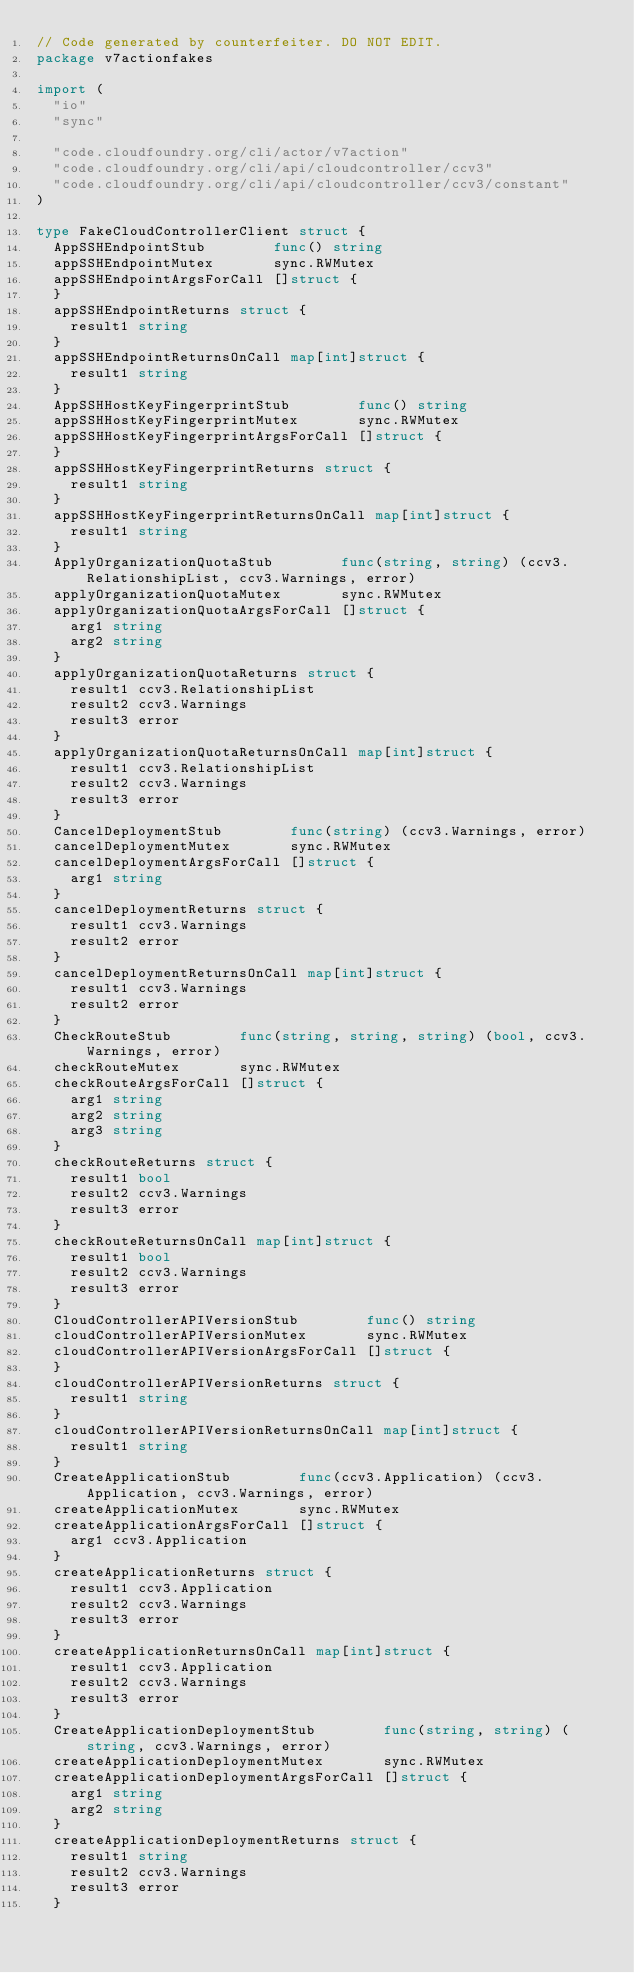Convert code to text. <code><loc_0><loc_0><loc_500><loc_500><_Go_>// Code generated by counterfeiter. DO NOT EDIT.
package v7actionfakes

import (
	"io"
	"sync"

	"code.cloudfoundry.org/cli/actor/v7action"
	"code.cloudfoundry.org/cli/api/cloudcontroller/ccv3"
	"code.cloudfoundry.org/cli/api/cloudcontroller/ccv3/constant"
)

type FakeCloudControllerClient struct {
	AppSSHEndpointStub        func() string
	appSSHEndpointMutex       sync.RWMutex
	appSSHEndpointArgsForCall []struct {
	}
	appSSHEndpointReturns struct {
		result1 string
	}
	appSSHEndpointReturnsOnCall map[int]struct {
		result1 string
	}
	AppSSHHostKeyFingerprintStub        func() string
	appSSHHostKeyFingerprintMutex       sync.RWMutex
	appSSHHostKeyFingerprintArgsForCall []struct {
	}
	appSSHHostKeyFingerprintReturns struct {
		result1 string
	}
	appSSHHostKeyFingerprintReturnsOnCall map[int]struct {
		result1 string
	}
	ApplyOrganizationQuotaStub        func(string, string) (ccv3.RelationshipList, ccv3.Warnings, error)
	applyOrganizationQuotaMutex       sync.RWMutex
	applyOrganizationQuotaArgsForCall []struct {
		arg1 string
		arg2 string
	}
	applyOrganizationQuotaReturns struct {
		result1 ccv3.RelationshipList
		result2 ccv3.Warnings
		result3 error
	}
	applyOrganizationQuotaReturnsOnCall map[int]struct {
		result1 ccv3.RelationshipList
		result2 ccv3.Warnings
		result3 error
	}
	CancelDeploymentStub        func(string) (ccv3.Warnings, error)
	cancelDeploymentMutex       sync.RWMutex
	cancelDeploymentArgsForCall []struct {
		arg1 string
	}
	cancelDeploymentReturns struct {
		result1 ccv3.Warnings
		result2 error
	}
	cancelDeploymentReturnsOnCall map[int]struct {
		result1 ccv3.Warnings
		result2 error
	}
	CheckRouteStub        func(string, string, string) (bool, ccv3.Warnings, error)
	checkRouteMutex       sync.RWMutex
	checkRouteArgsForCall []struct {
		arg1 string
		arg2 string
		arg3 string
	}
	checkRouteReturns struct {
		result1 bool
		result2 ccv3.Warnings
		result3 error
	}
	checkRouteReturnsOnCall map[int]struct {
		result1 bool
		result2 ccv3.Warnings
		result3 error
	}
	CloudControllerAPIVersionStub        func() string
	cloudControllerAPIVersionMutex       sync.RWMutex
	cloudControllerAPIVersionArgsForCall []struct {
	}
	cloudControllerAPIVersionReturns struct {
		result1 string
	}
	cloudControllerAPIVersionReturnsOnCall map[int]struct {
		result1 string
	}
	CreateApplicationStub        func(ccv3.Application) (ccv3.Application, ccv3.Warnings, error)
	createApplicationMutex       sync.RWMutex
	createApplicationArgsForCall []struct {
		arg1 ccv3.Application
	}
	createApplicationReturns struct {
		result1 ccv3.Application
		result2 ccv3.Warnings
		result3 error
	}
	createApplicationReturnsOnCall map[int]struct {
		result1 ccv3.Application
		result2 ccv3.Warnings
		result3 error
	}
	CreateApplicationDeploymentStub        func(string, string) (string, ccv3.Warnings, error)
	createApplicationDeploymentMutex       sync.RWMutex
	createApplicationDeploymentArgsForCall []struct {
		arg1 string
		arg2 string
	}
	createApplicationDeploymentReturns struct {
		result1 string
		result2 ccv3.Warnings
		result3 error
	}</code> 